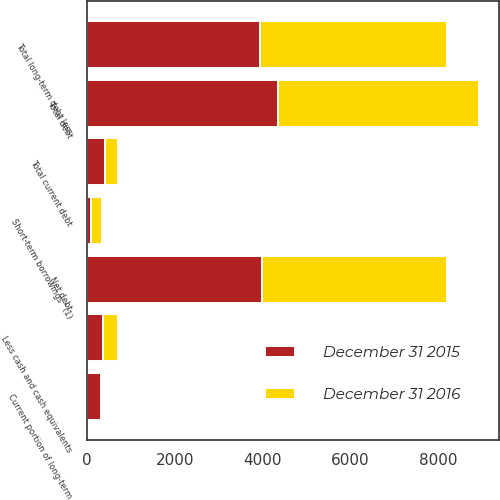Convert chart to OTSL. <chart><loc_0><loc_0><loc_500><loc_500><stacked_bar_chart><ecel><fcel>Short-term borrowings^(1)<fcel>Current portion of long-term<fcel>Total current debt<fcel>Total long-term debt less<fcel>Total debt<fcel>Less cash and cash equivalents<fcel>Net debt<nl><fcel>December 31 2015<fcel>92.6<fcel>328.1<fcel>420.7<fcel>3938.3<fcel>4359<fcel>363.7<fcel>3995.3<nl><fcel>December 31 2016<fcel>248.2<fcel>46.6<fcel>294.8<fcel>4266.8<fcel>4561.6<fcel>351.7<fcel>4209.9<nl></chart> 